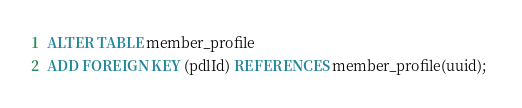Convert code to text. <code><loc_0><loc_0><loc_500><loc_500><_SQL_>ALTER TABLE member_profile
ADD FOREIGN KEY (pdlId) REFERENCES member_profile(uuid); </code> 